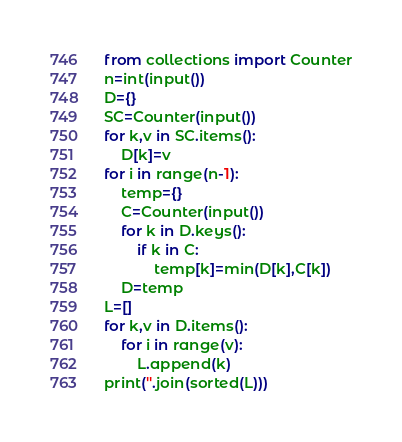Convert code to text. <code><loc_0><loc_0><loc_500><loc_500><_Python_>from collections import Counter
n=int(input())
D={}
SC=Counter(input())
for k,v in SC.items():
    D[k]=v
for i in range(n-1):
    temp={}
    C=Counter(input())
    for k in D.keys():
        if k in C:
            temp[k]=min(D[k],C[k])
    D=temp
L=[]
for k,v in D.items():
    for i in range(v):
        L.append(k)
print(''.join(sorted(L)))</code> 